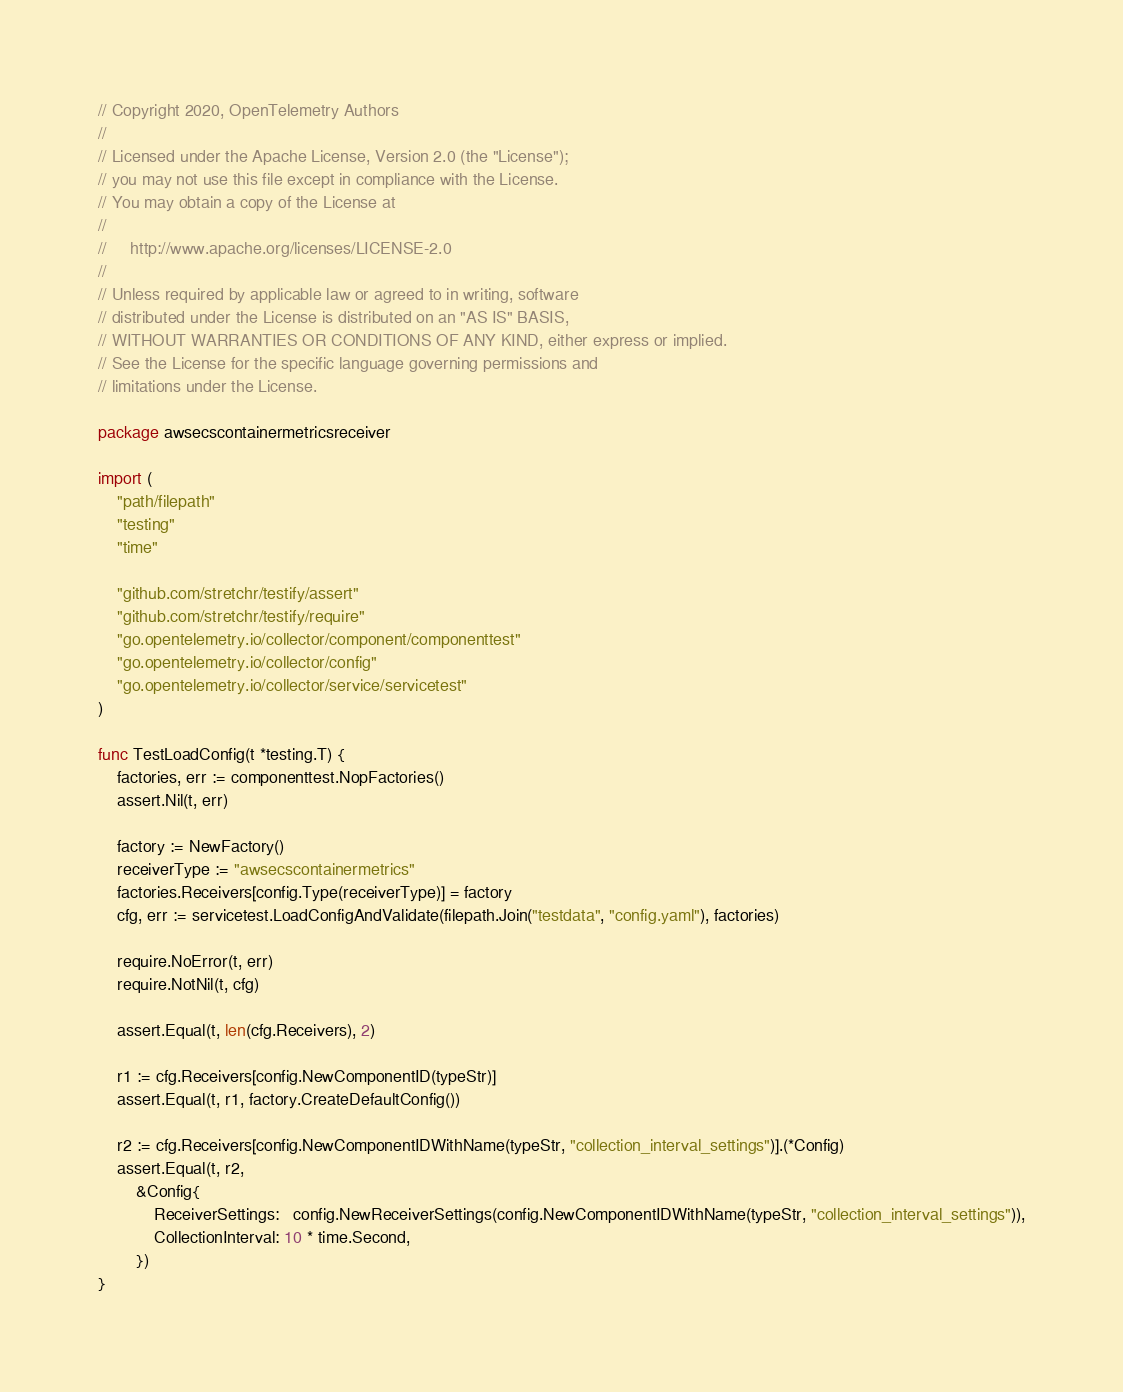Convert code to text. <code><loc_0><loc_0><loc_500><loc_500><_Go_>// Copyright 2020, OpenTelemetry Authors
//
// Licensed under the Apache License, Version 2.0 (the "License");
// you may not use this file except in compliance with the License.
// You may obtain a copy of the License at
//
//     http://www.apache.org/licenses/LICENSE-2.0
//
// Unless required by applicable law or agreed to in writing, software
// distributed under the License is distributed on an "AS IS" BASIS,
// WITHOUT WARRANTIES OR CONDITIONS OF ANY KIND, either express or implied.
// See the License for the specific language governing permissions and
// limitations under the License.

package awsecscontainermetricsreceiver

import (
	"path/filepath"
	"testing"
	"time"

	"github.com/stretchr/testify/assert"
	"github.com/stretchr/testify/require"
	"go.opentelemetry.io/collector/component/componenttest"
	"go.opentelemetry.io/collector/config"
	"go.opentelemetry.io/collector/service/servicetest"
)

func TestLoadConfig(t *testing.T) {
	factories, err := componenttest.NopFactories()
	assert.Nil(t, err)

	factory := NewFactory()
	receiverType := "awsecscontainermetrics"
	factories.Receivers[config.Type(receiverType)] = factory
	cfg, err := servicetest.LoadConfigAndValidate(filepath.Join("testdata", "config.yaml"), factories)

	require.NoError(t, err)
	require.NotNil(t, cfg)

	assert.Equal(t, len(cfg.Receivers), 2)

	r1 := cfg.Receivers[config.NewComponentID(typeStr)]
	assert.Equal(t, r1, factory.CreateDefaultConfig())

	r2 := cfg.Receivers[config.NewComponentIDWithName(typeStr, "collection_interval_settings")].(*Config)
	assert.Equal(t, r2,
		&Config{
			ReceiverSettings:   config.NewReceiverSettings(config.NewComponentIDWithName(typeStr, "collection_interval_settings")),
			CollectionInterval: 10 * time.Second,
		})
}
</code> 